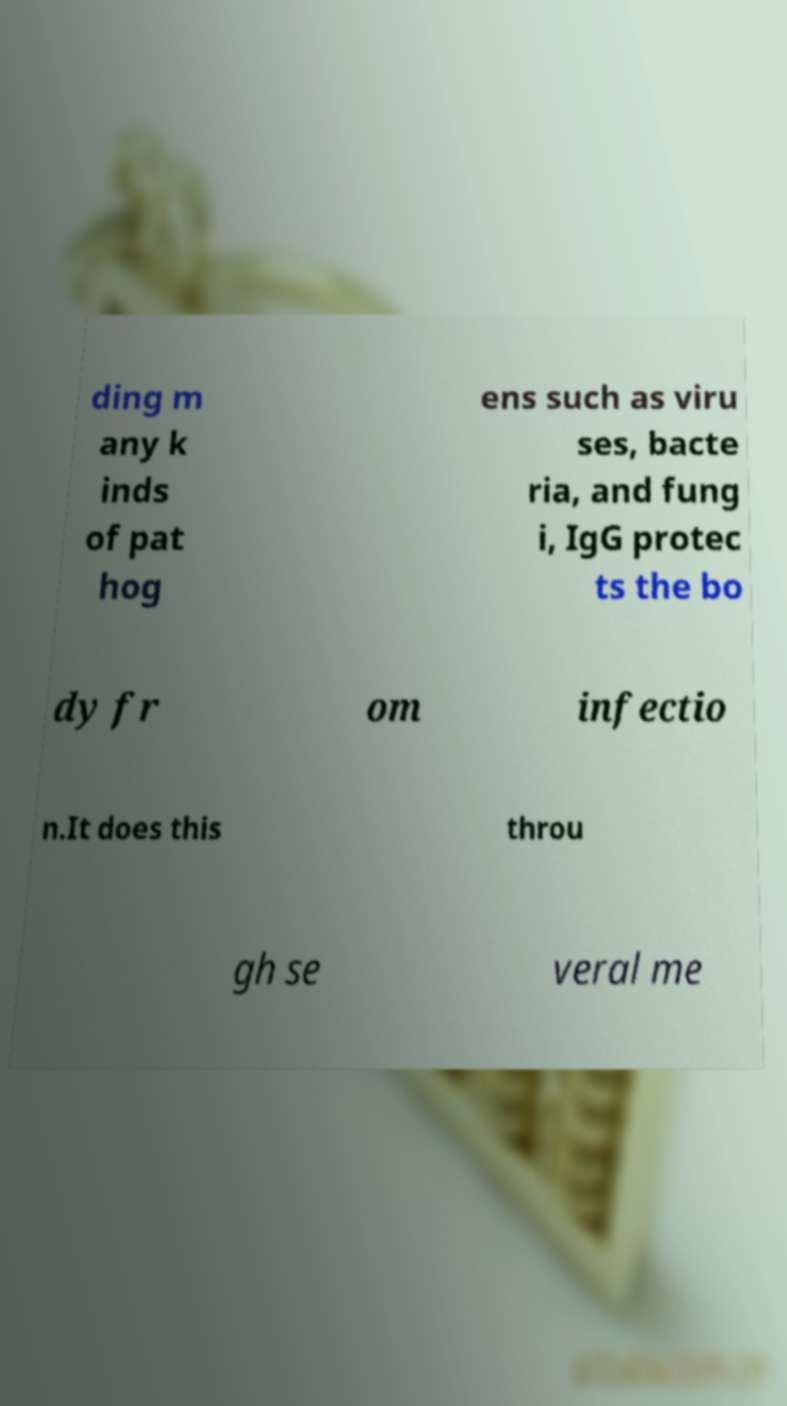Could you extract and type out the text from this image? ding m any k inds of pat hog ens such as viru ses, bacte ria, and fung i, IgG protec ts the bo dy fr om infectio n.It does this throu gh se veral me 